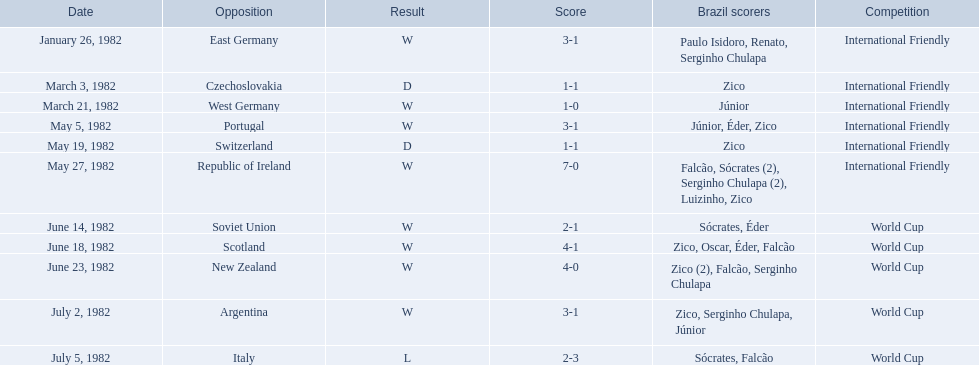What were the tallies of each game in the 1982 brazilian football matches? 3-1, 1-1, 1-0, 3-1, 1-1, 7-0, 2-1, 4-1, 4-0, 3-1, 2-3. Would you be able to parse every entry in this table? {'header': ['Date', 'Opposition', 'Result', 'Score', 'Brazil scorers', 'Competition'], 'rows': [['January 26, 1982', 'East Germany', 'W', '3-1', 'Paulo Isidoro, Renato, Serginho Chulapa', 'International Friendly'], ['March 3, 1982', 'Czechoslovakia', 'D', '1-1', 'Zico', 'International Friendly'], ['March 21, 1982', 'West Germany', 'W', '1-0', 'Júnior', 'International Friendly'], ['May 5, 1982', 'Portugal', 'W', '3-1', 'Júnior, Éder, Zico', 'International Friendly'], ['May 19, 1982', 'Switzerland', 'D', '1-1', 'Zico', 'International Friendly'], ['May 27, 1982', 'Republic of Ireland', 'W', '7-0', 'Falcão, Sócrates (2), Serginho Chulapa (2), Luizinho, Zico', 'International Friendly'], ['June 14, 1982', 'Soviet Union', 'W', '2-1', 'Sócrates, Éder', 'World Cup'], ['June 18, 1982', 'Scotland', 'W', '4-1', 'Zico, Oscar, Éder, Falcão', 'World Cup'], ['June 23, 1982', 'New Zealand', 'W', '4-0', 'Zico (2), Falcão, Serginho Chulapa', 'World Cup'], ['July 2, 1982', 'Argentina', 'W', '3-1', 'Zico, Serginho Chulapa, Júnior', 'World Cup'], ['July 5, 1982', 'Italy', 'L', '2-3', 'Sócrates, Falcão', 'World Cup']]} Of these, which were the scores from games versus portugal and the soviet union? 3-1, 2-1. And among those two games, against which country did brazil have a higher goal count? Portugal. 